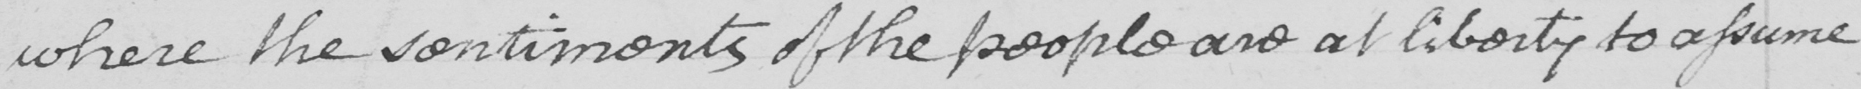What text is written in this handwritten line? where the sentiments of the people are at liberty to assume 